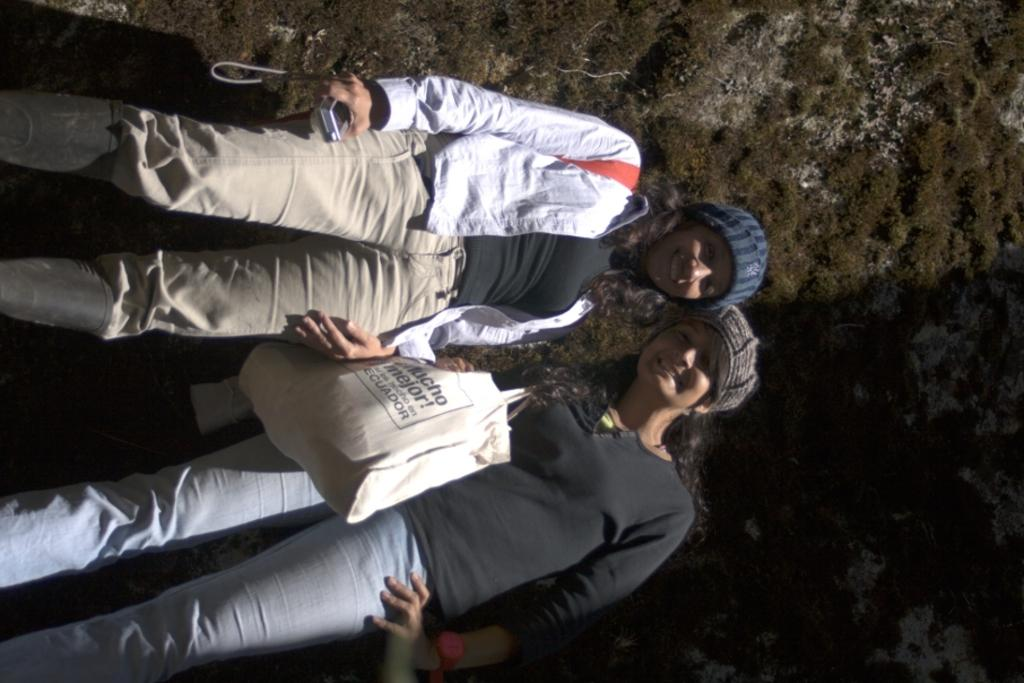How many people are in the image? There are two persons standing and smiling in the image. What are the people holding in the image? One person is holding a camera, and another person is holding a bag. What can be seen in the background of the image? There is a wall in the background of the image. What type of pickle is on the sofa in the image? There is no pickle or sofa present in the image. How many men are visible in the image? The image does not specify the gender of the two persons, so we cannot determine if they are men or not. 